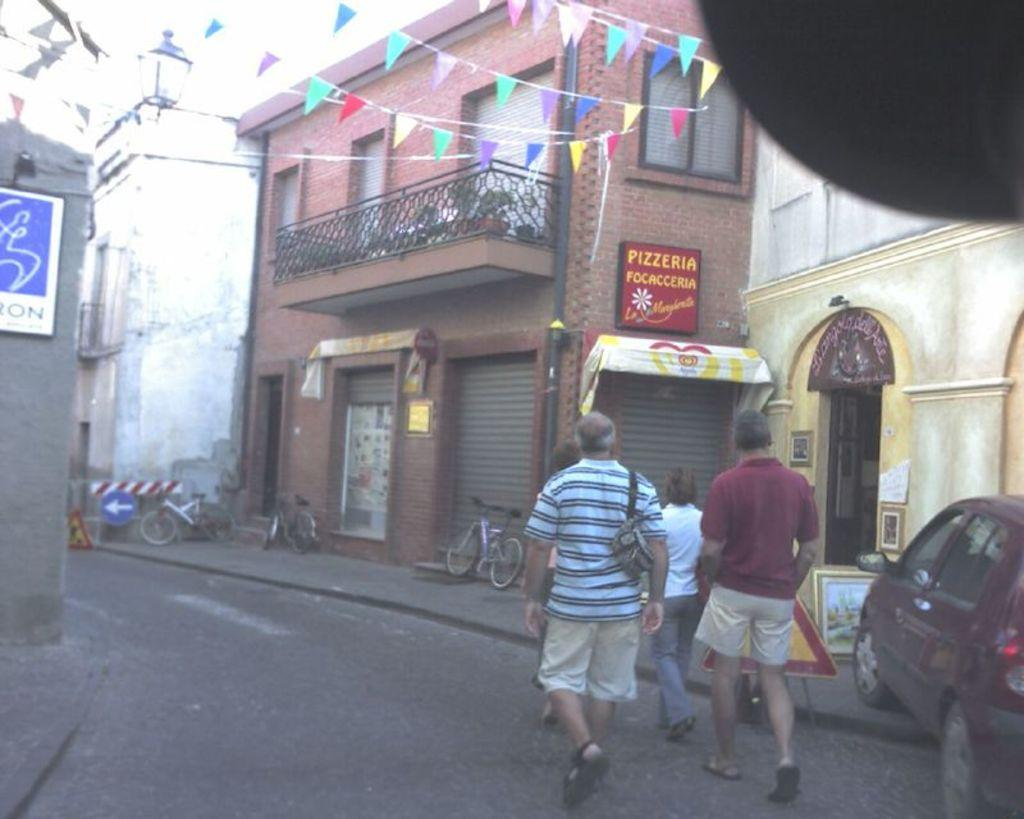What are the people in the image doing? People are walking on the road in the image. What else can be seen in the image besides people walking? There are vehicles, sign boards, pictures, flags, buildings, and bicycles in the image. Can you describe the sign boards in the image? The sign boards in the image provide information or directions. What is on the wall in the image? Boards are on the wall in the image. What advice is given by the tree in the image? There is no tree present in the image, so no advice can be given by a tree. 